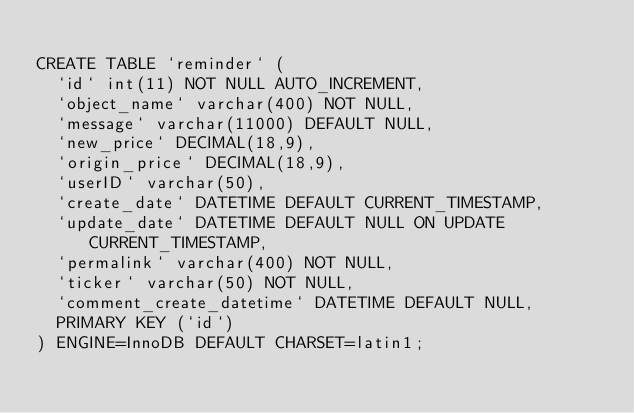Convert code to text. <code><loc_0><loc_0><loc_500><loc_500><_SQL_>
CREATE TABLE `reminder` (
  `id` int(11) NOT NULL AUTO_INCREMENT,
  `object_name` varchar(400) NOT NULL,
  `message` varchar(11000) DEFAULT NULL,
  `new_price` DECIMAL(18,9),
  `origin_price` DECIMAL(18,9),
  `userID` varchar(50),
  `create_date` DATETIME DEFAULT CURRENT_TIMESTAMP,
  `update_date` DATETIME DEFAULT NULL ON UPDATE CURRENT_TIMESTAMP,
  `permalink` varchar(400) NOT NULL,
  `ticker` varchar(50) NOT NULL,
  `comment_create_datetime` DATETIME DEFAULT NULL,
  PRIMARY KEY (`id`)
) ENGINE=InnoDB DEFAULT CHARSET=latin1;
</code> 